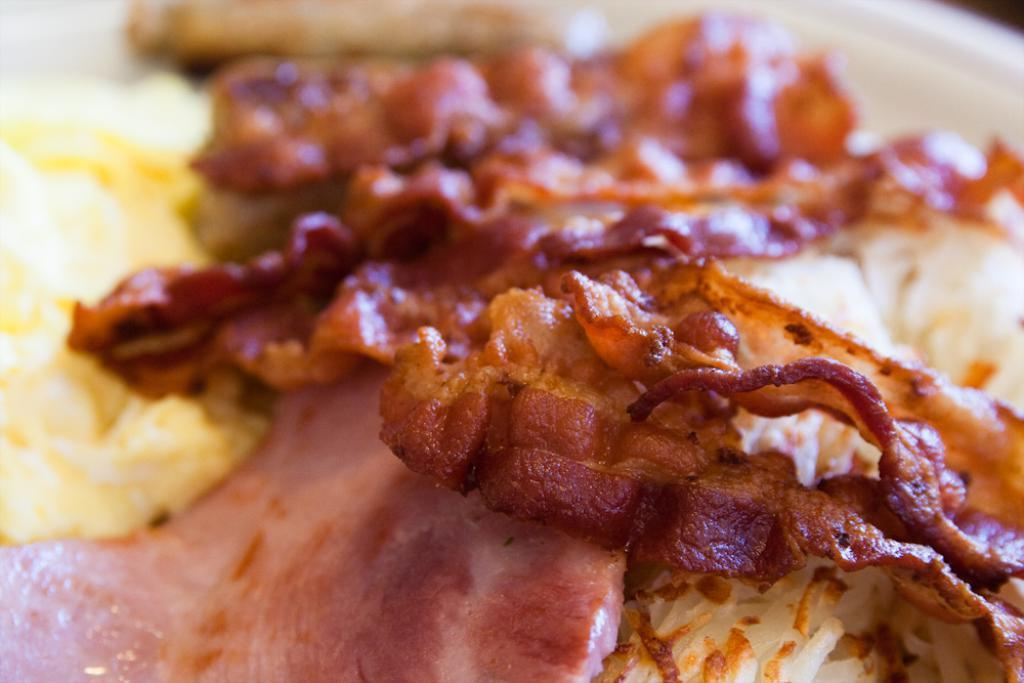What type of objects can be seen in the image? There are food items in the image. How much snow can be seen falling in the image? There is no snow present in the image; it features food items. What is the endpoint of the line in the image? There is no line present in the image. 